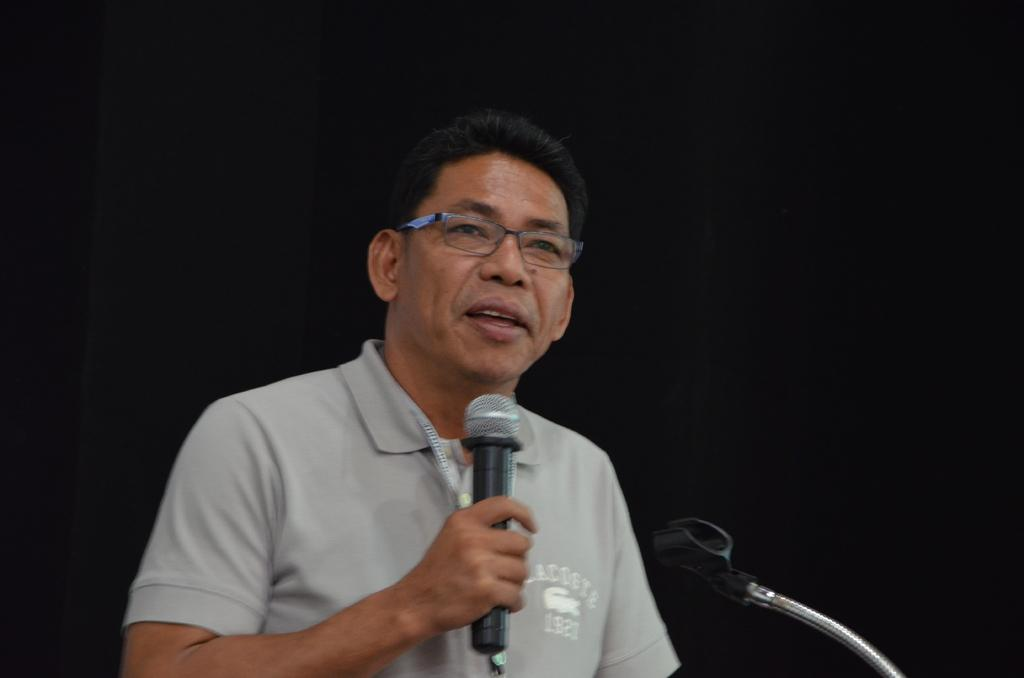Who is the main subject in the image? There is a man in the image. What is the man holding in his hand? The man is holding a microphone in his hand. What is the man doing in the image? The man is talking. Can you describe the man's appearance? The man is wearing spectacles. What else can be seen in the image related to the microphone? There is a microphone stand in the image. What type of rock is the man standing on in the image? There is no rock visible in the image; the man is likely standing on a floor or stage. Can you tell me how many goldfish are swimming in the background of the image? There are no goldfish present in the image. 